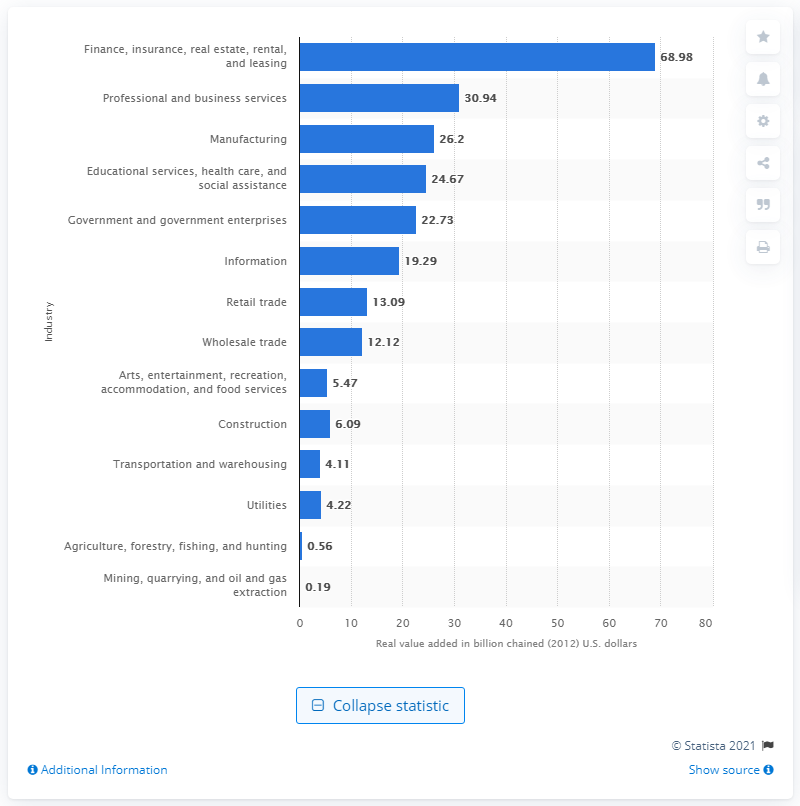How much money did the finance, insurance, real estate, rental, and leasing industry contribute to Connecticut's GDP in 2020?
 68.98 